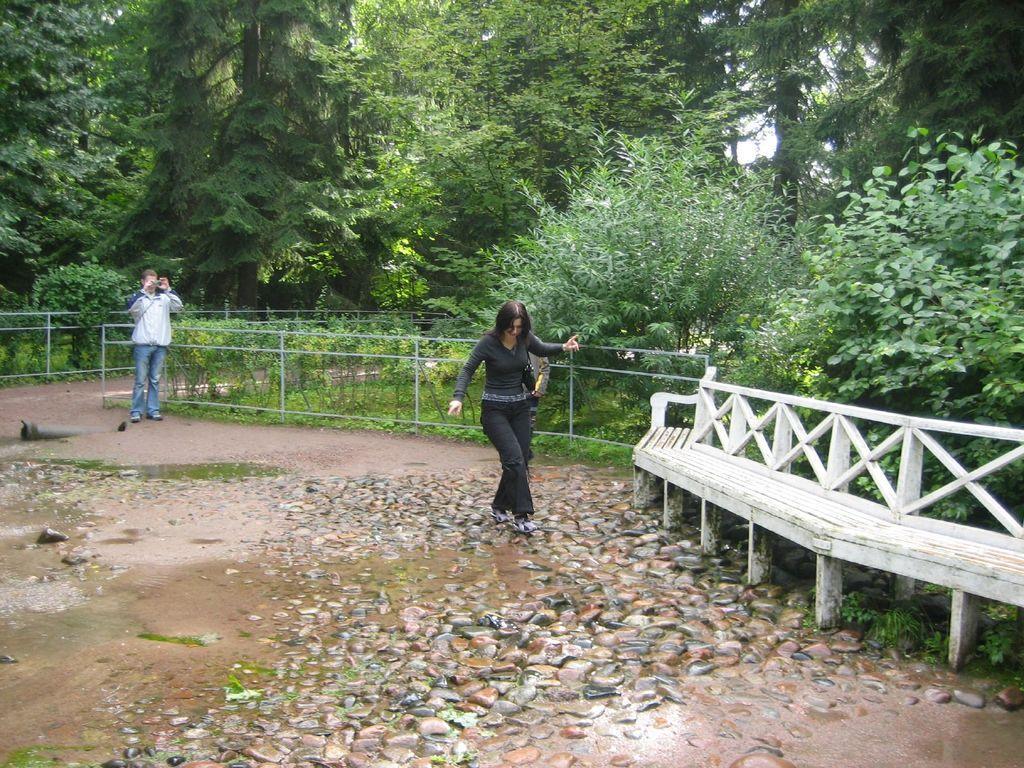Describe this image in one or two sentences. In this image we can see a man and a woman. Here we can see stones, groundwater, bench, fence, plants, and trees. In the background there is sky. 